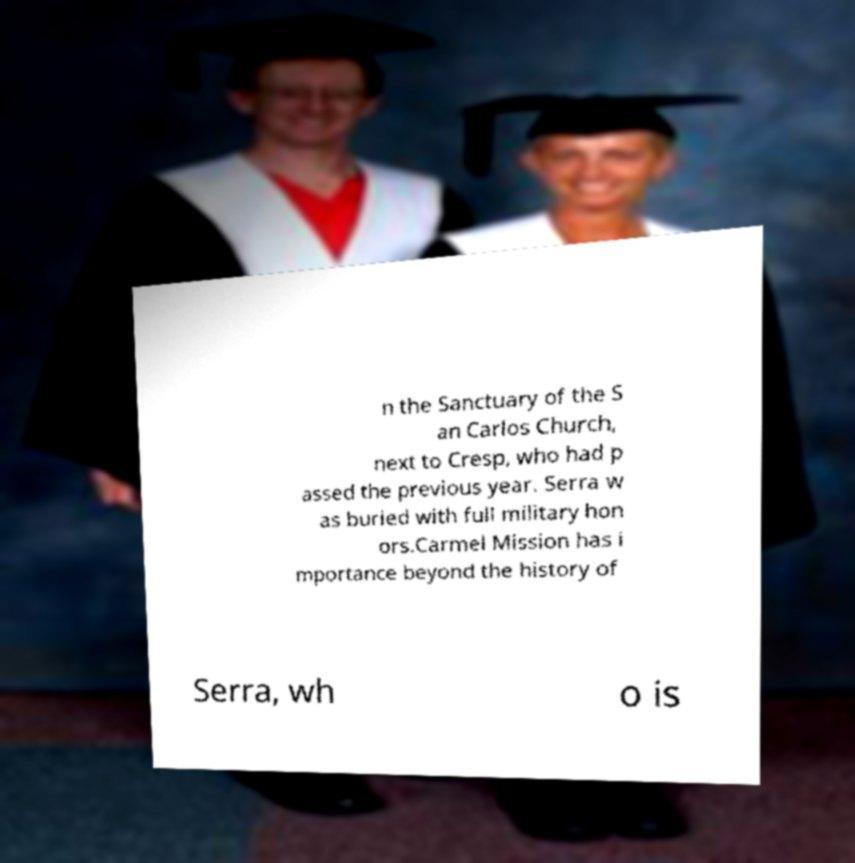There's text embedded in this image that I need extracted. Can you transcribe it verbatim? n the Sanctuary of the S an Carlos Church, next to Cresp, who had p assed the previous year. Serra w as buried with full military hon ors.Carmel Mission has i mportance beyond the history of Serra, wh o is 